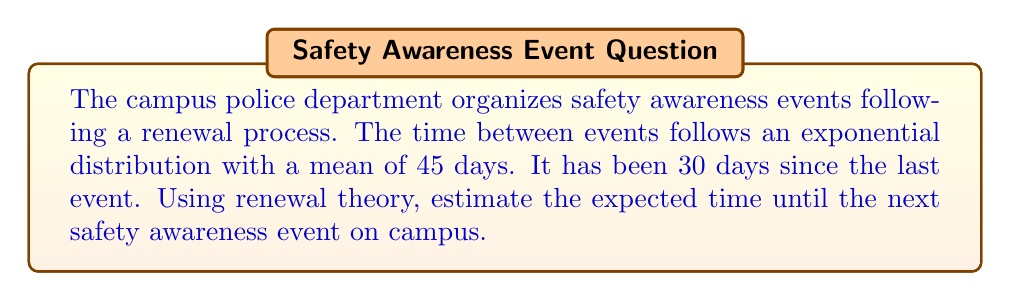What is the answer to this math problem? Let's approach this step-by-step using renewal theory:

1) In renewal theory, for an exponential distribution, we can use the memoryless property. This means that regardless of how much time has passed since the last event, the expected time until the next event remains the same as the mean of the distribution.

2) The mean time between events is given as 45 days. Let's denote this as $\mu = 45$.

3) For an exponential distribution, the rate parameter $\lambda$ is the inverse of the mean:

   $\lambda = \frac{1}{\mu} = \frac{1}{45}$

4) The expected time until the next event, given that 30 days have passed, is still equal to the mean of the distribution due to the memoryless property:

   $E[T] = \mu = 45$ days

5) This result is independent of the 30 days that have already passed. In other words, the expected additional time until the next event is always 45 days, regardless of how long it's been since the last event.

Therefore, the estimated time until the next safety awareness event is 45 days from now.
Answer: 45 days 